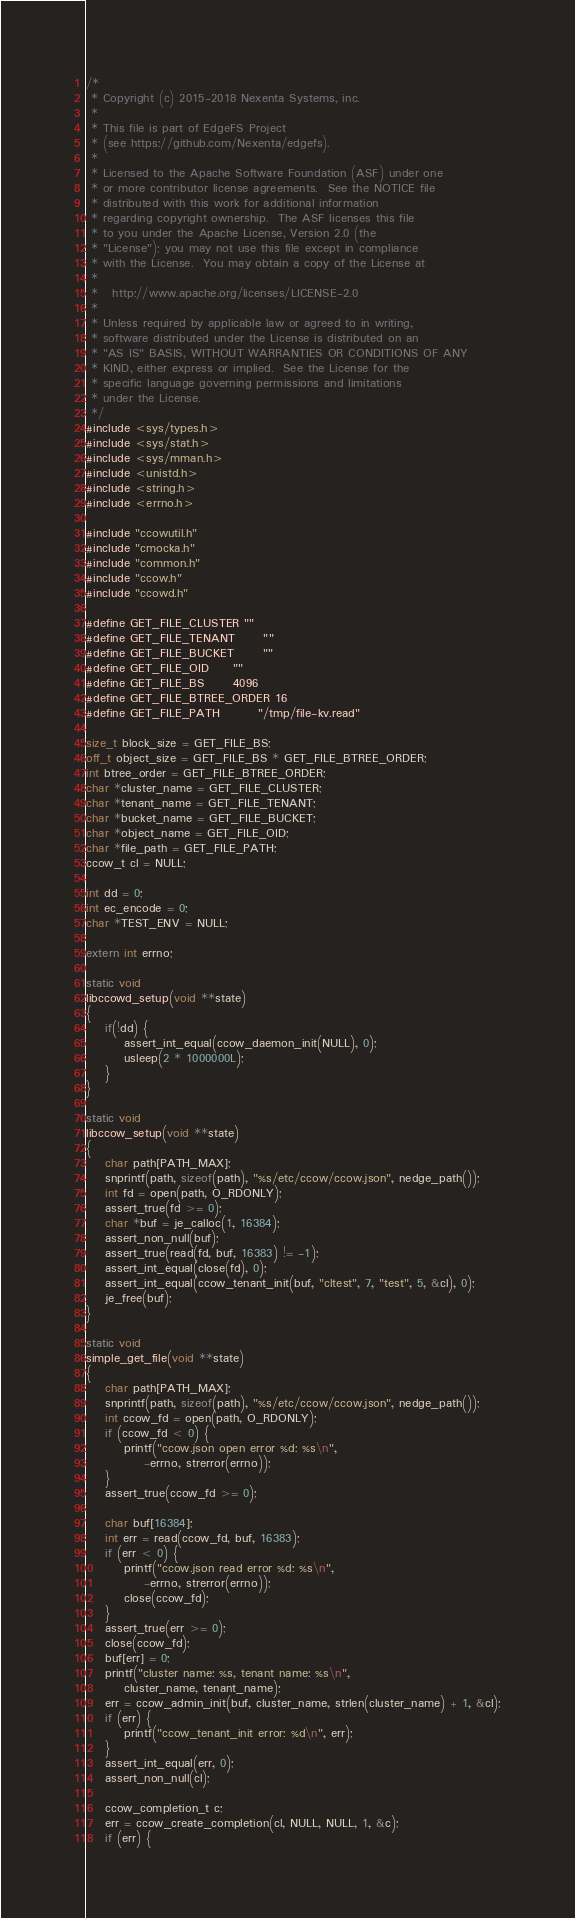Convert code to text. <code><loc_0><loc_0><loc_500><loc_500><_C_>/*
 * Copyright (c) 2015-2018 Nexenta Systems, inc.
 *
 * This file is part of EdgeFS Project
 * (see https://github.com/Nexenta/edgefs).
 *
 * Licensed to the Apache Software Foundation (ASF) under one
 * or more contributor license agreements.  See the NOTICE file
 * distributed with this work for additional information
 * regarding copyright ownership.  The ASF licenses this file
 * to you under the Apache License, Version 2.0 (the
 * "License"); you may not use this file except in compliance
 * with the License.  You may obtain a copy of the License at
 *
 *   http://www.apache.org/licenses/LICENSE-2.0
 *
 * Unless required by applicable law or agreed to in writing,
 * software distributed under the License is distributed on an
 * "AS IS" BASIS, WITHOUT WARRANTIES OR CONDITIONS OF ANY
 * KIND, either express or implied.  See the License for the
 * specific language governing permissions and limitations
 * under the License.
 */
#include <sys/types.h>
#include <sys/stat.h>
#include <sys/mman.h>
#include <unistd.h>
#include <string.h>
#include <errno.h>

#include "ccowutil.h"
#include "cmocka.h"
#include "common.h"
#include "ccow.h"
#include "ccowd.h"

#define GET_FILE_CLUSTER	""
#define GET_FILE_TENANT		""
#define GET_FILE_BUCKET		""
#define GET_FILE_OID		""
#define GET_FILE_BS		4096
#define GET_FILE_BTREE_ORDER	16
#define GET_FILE_PATH		"/tmp/file-kv.read"

size_t block_size = GET_FILE_BS;
off_t object_size = GET_FILE_BS * GET_FILE_BTREE_ORDER;
int btree_order = GET_FILE_BTREE_ORDER;
char *cluster_name = GET_FILE_CLUSTER;
char *tenant_name = GET_FILE_TENANT;
char *bucket_name = GET_FILE_BUCKET;
char *object_name = GET_FILE_OID;
char *file_path = GET_FILE_PATH;
ccow_t cl = NULL;

int dd = 0;
int ec_encode = 0;
char *TEST_ENV = NULL;

extern int errno;

static void
libccowd_setup(void **state)
{
    if(!dd) {
        assert_int_equal(ccow_daemon_init(NULL), 0);
        usleep(2 * 1000000L);
    }
}

static void
libccow_setup(void **state)
{
	char path[PATH_MAX];
	snprintf(path, sizeof(path), "%s/etc/ccow/ccow.json", nedge_path());
	int fd = open(path, O_RDONLY);
	assert_true(fd >= 0);
	char *buf = je_calloc(1, 16384);
	assert_non_null(buf);
	assert_true(read(fd, buf, 16383) != -1);
	assert_int_equal(close(fd), 0);
	assert_int_equal(ccow_tenant_init(buf, "cltest", 7, "test", 5, &cl), 0);
	je_free(buf);
}

static void
simple_get_file(void **state)
{
	char path[PATH_MAX];
	snprintf(path, sizeof(path), "%s/etc/ccow/ccow.json", nedge_path());
	int ccow_fd = open(path, O_RDONLY);
	if (ccow_fd < 0) {
		printf("ccow.json open error %d: %s\n",
			-errno, strerror(errno));
	}
	assert_true(ccow_fd >= 0);

	char buf[16384];
	int err = read(ccow_fd, buf, 16383);
	if (err < 0) {
		printf("ccow.json read error %d: %s\n",
			-errno, strerror(errno));
		close(ccow_fd);
	}
	assert_true(err >= 0);
	close(ccow_fd);
	buf[err] = 0;
	printf("cluster name: %s, tenant name: %s\n",
		cluster_name, tenant_name);
	err = ccow_admin_init(buf, cluster_name, strlen(cluster_name) + 1, &cl);
	if (err) {
		printf("ccow_tenant_init error: %d\n", err);
	}
	assert_int_equal(err, 0);
	assert_non_null(cl);

	ccow_completion_t c;
	err = ccow_create_completion(cl, NULL, NULL, 1, &c);
	if (err) {</code> 